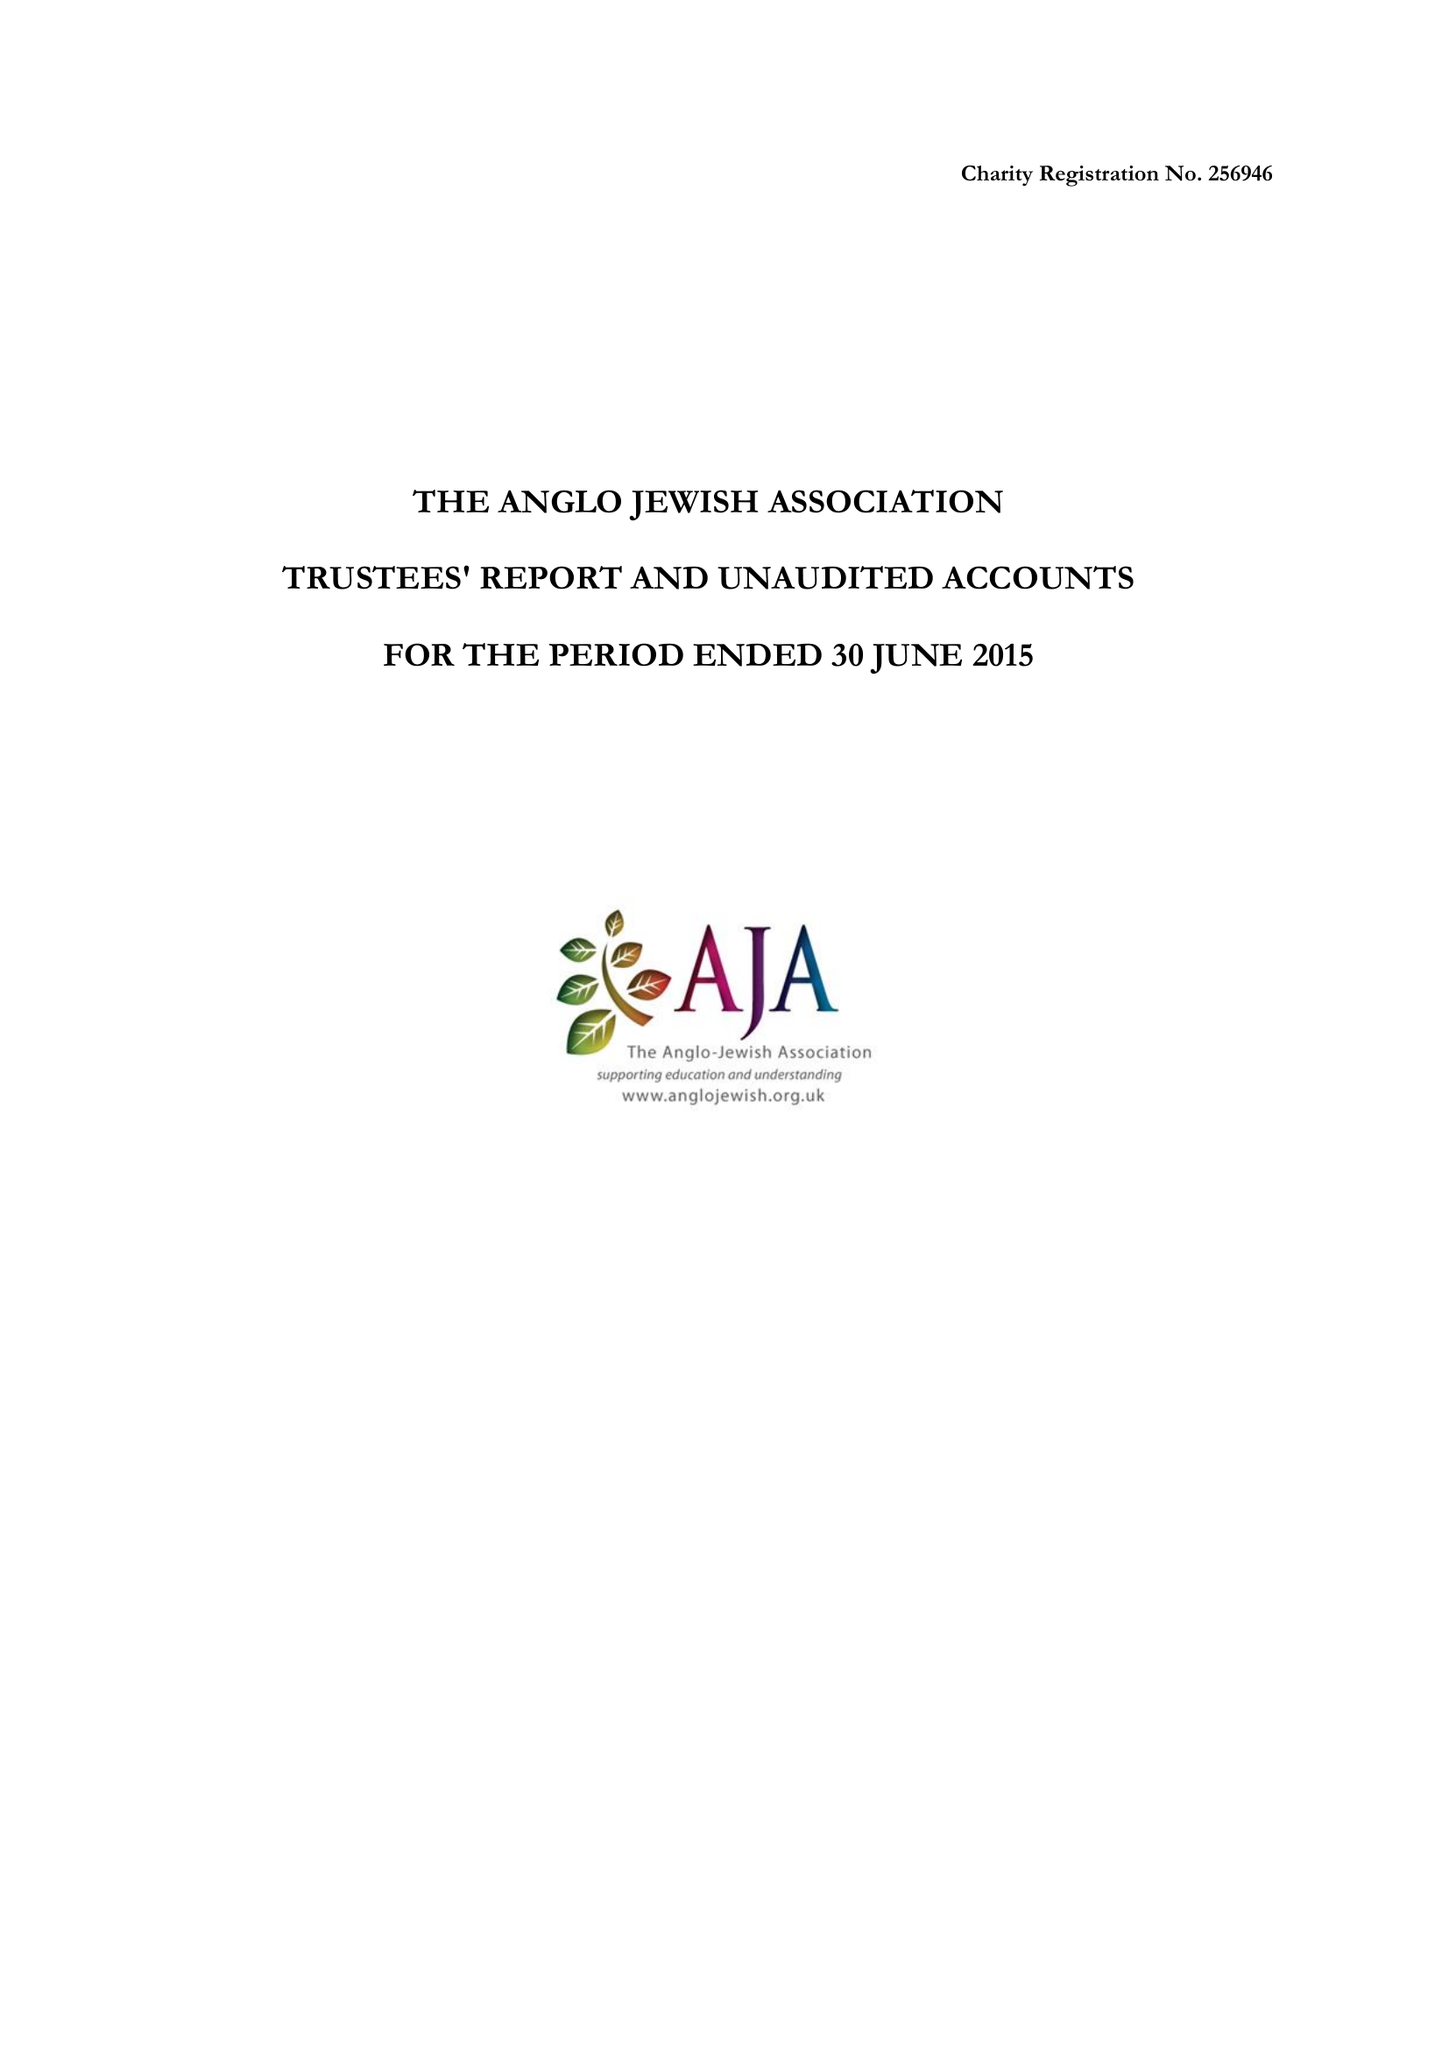What is the value for the address__post_town?
Answer the question using a single word or phrase. LONDON 